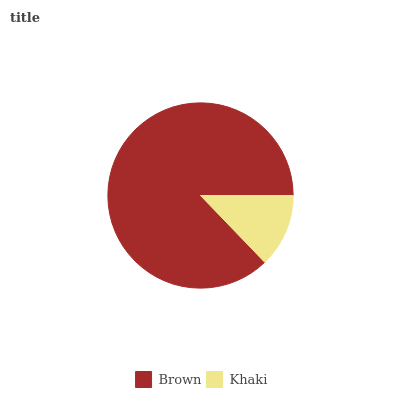Is Khaki the minimum?
Answer yes or no. Yes. Is Brown the maximum?
Answer yes or no. Yes. Is Khaki the maximum?
Answer yes or no. No. Is Brown greater than Khaki?
Answer yes or no. Yes. Is Khaki less than Brown?
Answer yes or no. Yes. Is Khaki greater than Brown?
Answer yes or no. No. Is Brown less than Khaki?
Answer yes or no. No. Is Brown the high median?
Answer yes or no. Yes. Is Khaki the low median?
Answer yes or no. Yes. Is Khaki the high median?
Answer yes or no. No. Is Brown the low median?
Answer yes or no. No. 